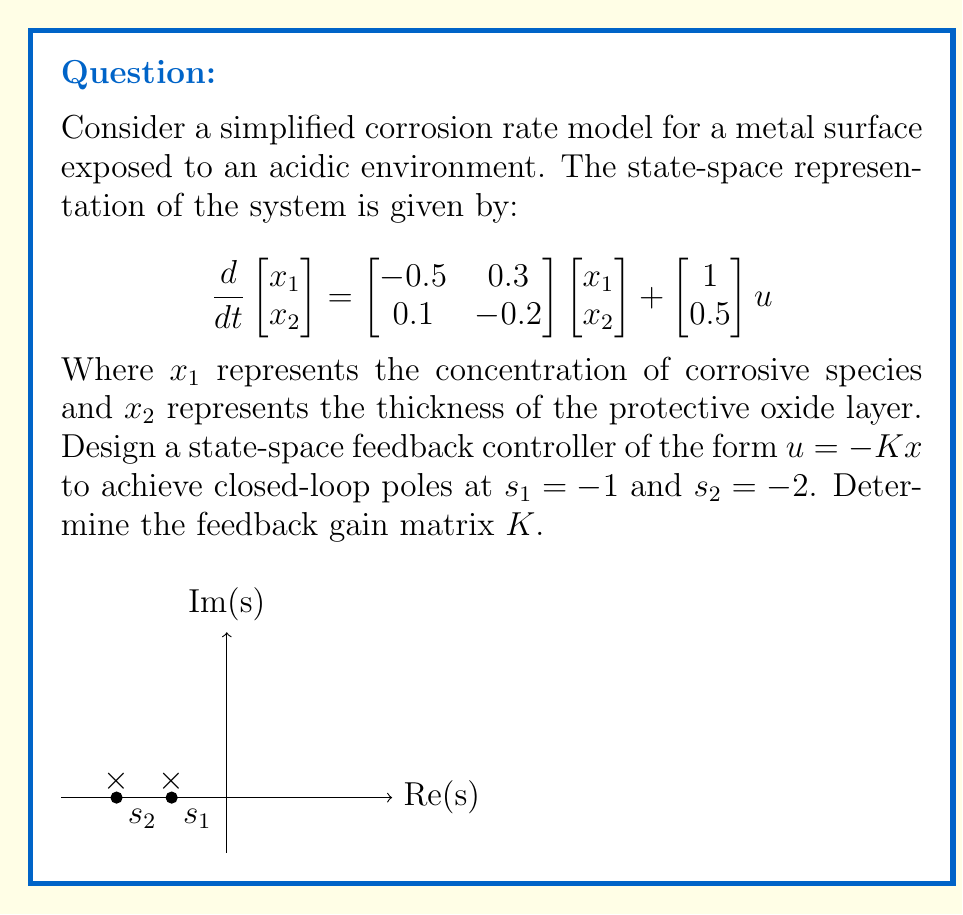Show me your answer to this math problem. To design the state-space feedback controller, we'll follow these steps:

1) The closed-loop system with feedback $u = -Kx$ is given by:
   $$\frac{d}{dt}x = (A - BK)x$$
   where $A = \begin{bmatrix} -0.5 & 0.3 \\ 0.1 & -0.2 \end{bmatrix}$ and $B = \begin{bmatrix} 1 \\ 0.5 \end{bmatrix}$

2) The characteristic equation of the closed-loop system should be:
   $$\det(sI - (A - BK)) = (s + 1)(s + 2) = s^2 + 3s + 2$$

3) Expand $\det(sI - (A - BK))$:
   $$\begin{vmatrix} 
   s+0.5+k_1 & -0.3+k_2 \\
   -0.1+0.5k_1 & s+0.2+0.5k_2
   \end{vmatrix}$$
   $= (s+0.5+k_1)(s+0.2+0.5k_2) - (-0.3+k_2)(-0.1+0.5k_1)$
   $= s^2 + (0.7+k_1+0.5k_2)s + (0.1+0.5k_1+0.2k_2+0.5k_1k_2) + 0.03-0.1k_2-0.3k_1+0.5k_1k_2$
   $= s^2 + (0.7+k_1+0.5k_2)s + (0.13+0.2k_1+0.1k_2+k_1k_2)$

4) Equating coefficients with the desired characteristic equation:
   $0.7+k_1+0.5k_2 = 3$
   $0.13+0.2k_1+0.1k_2+k_1k_2 = 2$

5) Solving these equations:
   From the first equation: $k_2 = 4.6 - 2k_1$
   Substituting into the second equation:
   $0.13+0.2k_1+0.1(4.6-2k_1)+k_1(4.6-2k_1) = 2$
   $0.13+0.2k_1+0.46-0.2k_1+4.6k_1-2k_1^2 = 2$
   $2k_1^2-4.6k_1+1.41 = 0$
   
   Solving this quadratic equation:
   $k_1 = \frac{4.6 \pm \sqrt{4.6^2-4(2)(1.41)}}{2(2)} = \frac{4.6 \pm \sqrt{15.64}}{4} = \frac{4.6 \pm 3.955}{4}$
   
   Taking the positive root: $k_1 = 2.14$
   
   Then $k_2 = 4.6 - 2(2.14) = 0.32$

Therefore, the feedback gain matrix is $K = [2.14 \quad 0.32]$.
Answer: $K = [2.14 \quad 0.32]$ 